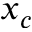Convert formula to latex. <formula><loc_0><loc_0><loc_500><loc_500>x _ { c }</formula> 